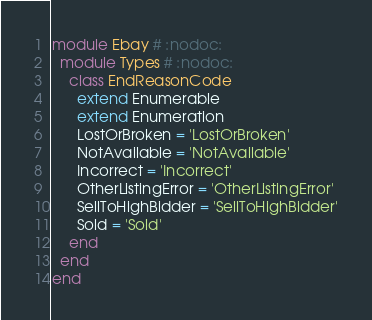Convert code to text. <code><loc_0><loc_0><loc_500><loc_500><_Ruby_>module Ebay # :nodoc:
  module Types # :nodoc:
    class EndReasonCode
      extend Enumerable
      extend Enumeration
      LostOrBroken = 'LostOrBroken'
      NotAvailable = 'NotAvailable'
      Incorrect = 'Incorrect'
      OtherListingError = 'OtherListingError'
      SellToHighBidder = 'SellToHighBidder'
      Sold = 'Sold'
    end
  end
end

</code> 